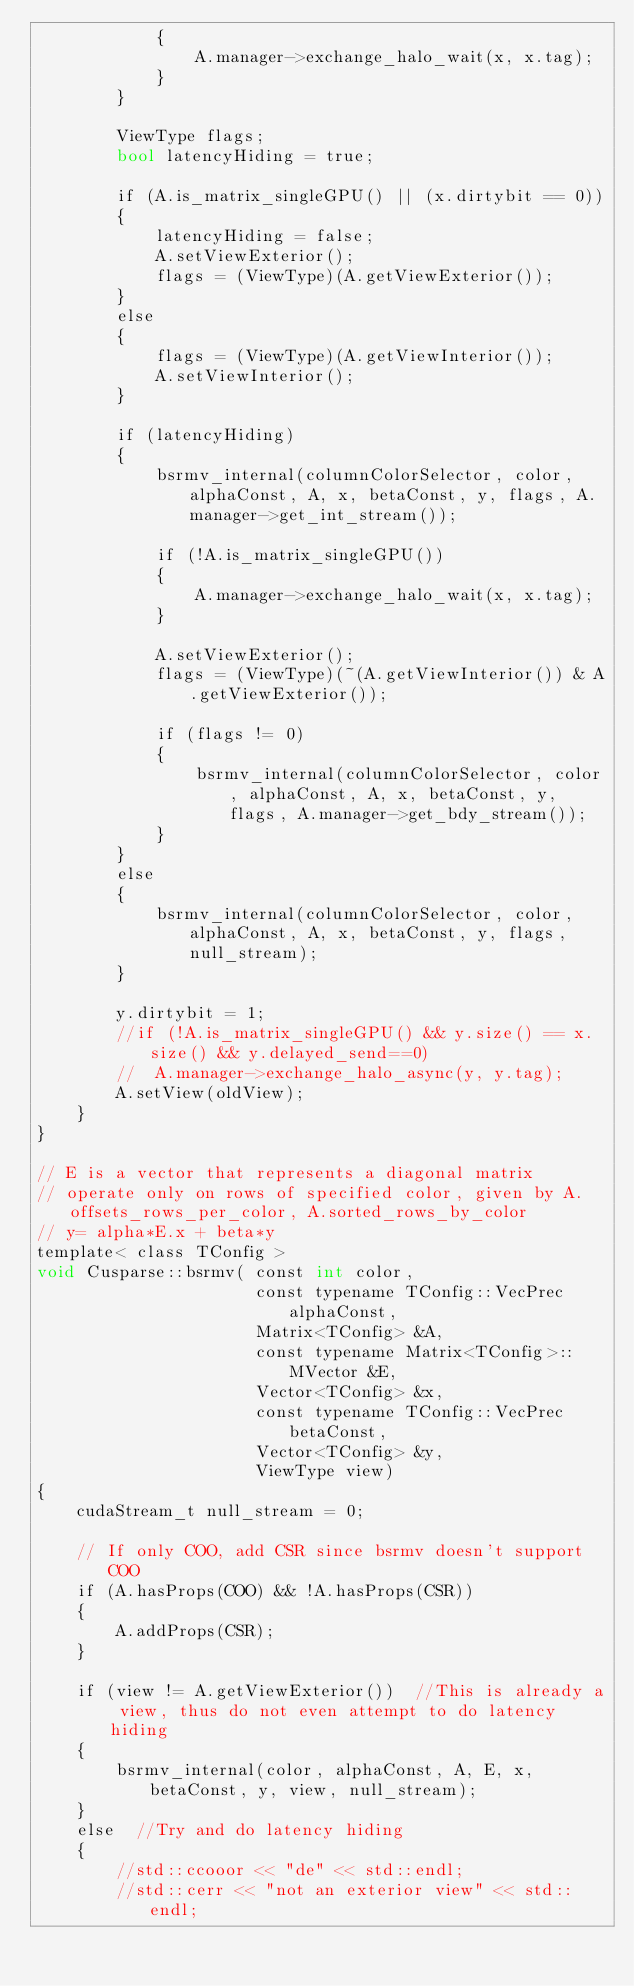Convert code to text. <code><loc_0><loc_0><loc_500><loc_500><_Cuda_>            {
                A.manager->exchange_halo_wait(x, x.tag);
            }
        }

        ViewType flags;
        bool latencyHiding = true;

        if (A.is_matrix_singleGPU() || (x.dirtybit == 0))
        {
            latencyHiding = false;
            A.setViewExterior();
            flags = (ViewType)(A.getViewExterior());
        }
        else
        {
            flags = (ViewType)(A.getViewInterior());
            A.setViewInterior();
        }

        if (latencyHiding)
        {
            bsrmv_internal(columnColorSelector, color, alphaConst, A, x, betaConst, y, flags, A.manager->get_int_stream());

            if (!A.is_matrix_singleGPU())
            {
                A.manager->exchange_halo_wait(x, x.tag);
            }

            A.setViewExterior();
            flags = (ViewType)(~(A.getViewInterior()) & A.getViewExterior());

            if (flags != 0)
            {
                bsrmv_internal(columnColorSelector, color, alphaConst, A, x, betaConst, y, flags, A.manager->get_bdy_stream());
            }
        }
        else
        {
            bsrmv_internal(columnColorSelector, color, alphaConst, A, x, betaConst, y, flags, null_stream);
        }

        y.dirtybit = 1;
        //if (!A.is_matrix_singleGPU() && y.size() == x.size() && y.delayed_send==0)
        //  A.manager->exchange_halo_async(y, y.tag);
        A.setView(oldView);
    }
}

// E is a vector that represents a diagonal matrix
// operate only on rows of specified color, given by A.offsets_rows_per_color, A.sorted_rows_by_color
// y= alpha*E.x + beta*y
template< class TConfig >
void Cusparse::bsrmv( const int color,
                      const typename TConfig::VecPrec alphaConst,
                      Matrix<TConfig> &A,
                      const typename Matrix<TConfig>::MVector &E,
                      Vector<TConfig> &x,
                      const typename TConfig::VecPrec betaConst,
                      Vector<TConfig> &y,
                      ViewType view)
{
    cudaStream_t null_stream = 0;

    // If only COO, add CSR since bsrmv doesn't support COO
    if (A.hasProps(COO) && !A.hasProps(CSR))
    {
        A.addProps(CSR);
    }

    if (view != A.getViewExterior())  //This is already a view, thus do not even attempt to do latency hiding
    {
        bsrmv_internal(color, alphaConst, A, E, x, betaConst, y, view, null_stream);
    }
    else  //Try and do latency hiding
    {
        //std::ccooor << "de" << std::endl;
        //std::cerr << "not an exterior view" << std::endl;</code> 